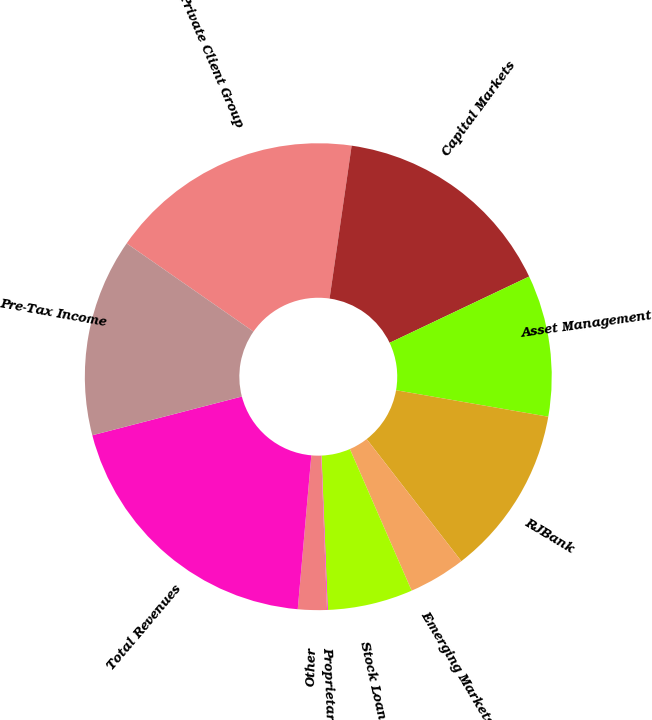<chart> <loc_0><loc_0><loc_500><loc_500><pie_chart><fcel>Private Client Group<fcel>Capital Markets<fcel>Asset Management<fcel>RJBank<fcel>Emerging Markets<fcel>Stock Loan/Borrow<fcel>Proprietary Capital<fcel>Other<fcel>Total Revenues<fcel>Pre-Tax Income<nl><fcel>17.61%<fcel>15.66%<fcel>9.8%<fcel>11.76%<fcel>3.95%<fcel>5.9%<fcel>0.05%<fcel>2.0%<fcel>19.56%<fcel>13.71%<nl></chart> 